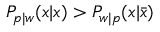<formula> <loc_0><loc_0><loc_500><loc_500>P _ { p | w } ( x | x ) > P _ { w | p } ( x | \bar { x } )</formula> 